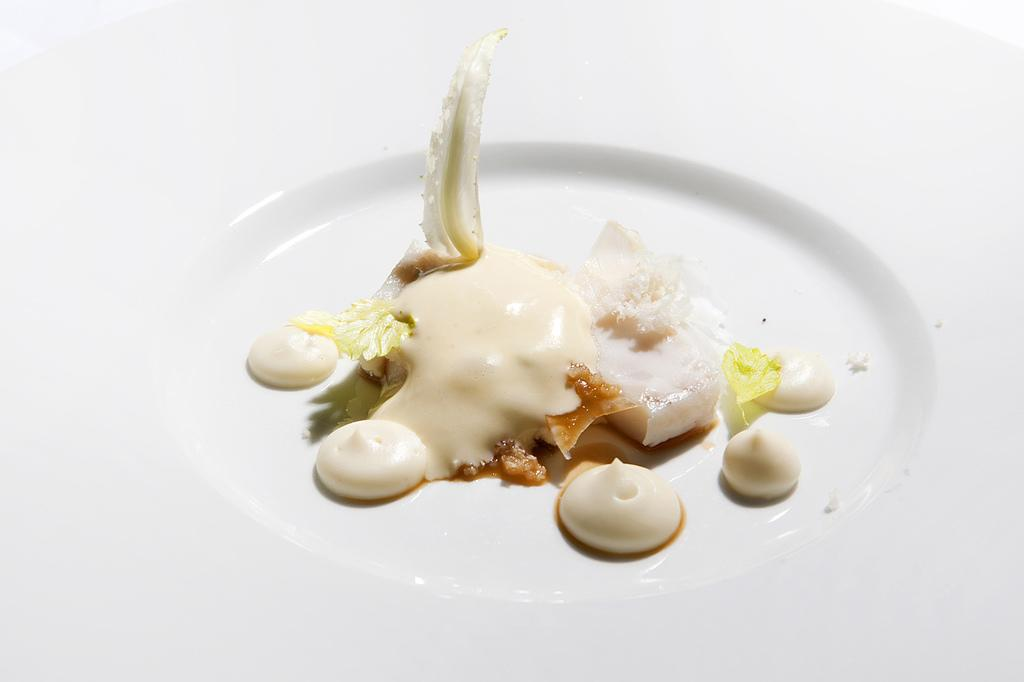What is present on the plate in the image? There are food items on a white color plate in the image. Can you describe the color of the plate? The plate is white in color. What type of relation is depicted between the food items and the apple in the image? There is no apple present in the image, so it is not possible to determine any relation between the food items and an apple. 